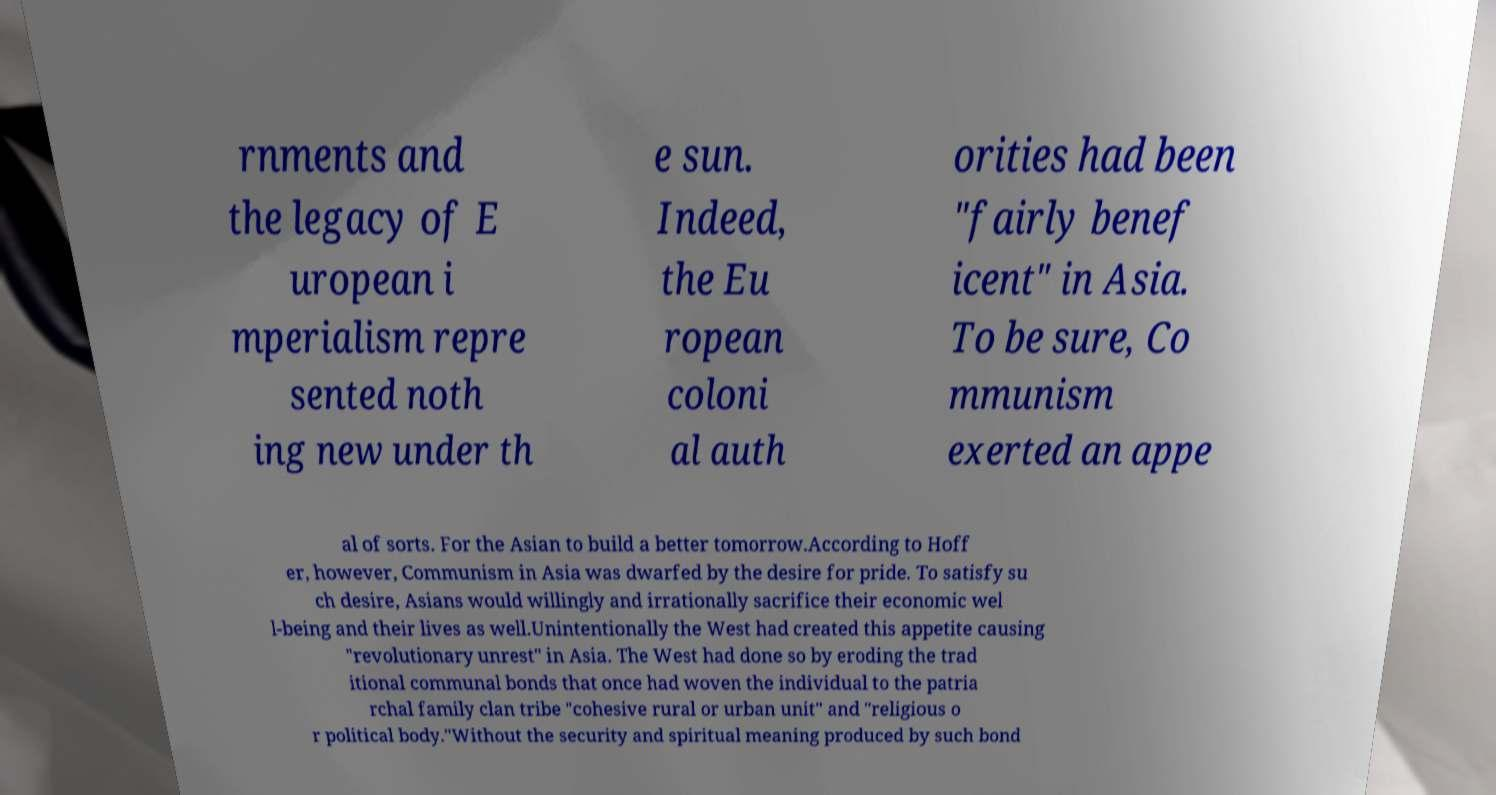Please identify and transcribe the text found in this image. rnments and the legacy of E uropean i mperialism repre sented noth ing new under th e sun. Indeed, the Eu ropean coloni al auth orities had been "fairly benef icent" in Asia. To be sure, Co mmunism exerted an appe al of sorts. For the Asian to build a better tomorrow.According to Hoff er, however, Communism in Asia was dwarfed by the desire for pride. To satisfy su ch desire, Asians would willingly and irrationally sacrifice their economic wel l-being and their lives as well.Unintentionally the West had created this appetite causing "revolutionary unrest" in Asia. The West had done so by eroding the trad itional communal bonds that once had woven the individual to the patria rchal family clan tribe "cohesive rural or urban unit" and "religious o r political body."Without the security and spiritual meaning produced by such bond 